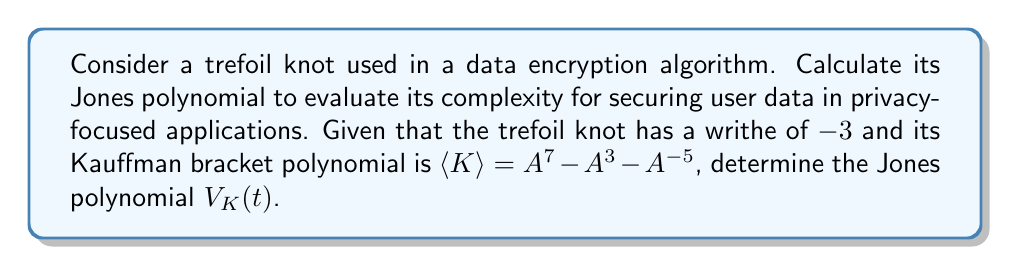Could you help me with this problem? To calculate the Jones polynomial for the trefoil knot, we'll follow these steps:

1. Recall the relation between the Jones polynomial $V_K(t)$ and the Kauffman bracket polynomial $\langle K \rangle$:

   $$V_K(t) = (-A^{-3})^{-w(K)} \cdot \langle K \rangle|_{A = t^{-1/4}}$$

   where $w(K)$ is the writhe of the knot.

2. We're given that the writhe $w(K) = -3$ and $\langle K \rangle = A^7 - A^3 - A^{-5}$.

3. Substitute these values into the formula:

   $$V_K(t) = (-A^{-3})^{-(-3)} \cdot (A^7 - A^3 - A^{-5})|_{A = t^{-1/4}}$$

4. Simplify the first part:

   $$V_K(t) = (-A^{-3})^3 \cdot (A^7 - A^3 - A^{-5})|_{A = t^{-1/4}}$$
   $$V_K(t) = -A^{-9} \cdot (A^7 - A^3 - A^{-5})|_{A = t^{-1/4}}$$

5. Now substitute $A = t^{-1/4}$:

   $$V_K(t) = -(t^{-1/4})^{-9} \cdot ((t^{-1/4})^7 - (t^{-1/4})^3 - (t^{-1/4})^{-5})$$

6. Simplify the exponents:

   $$V_K(t) = -t^{9/4} \cdot (t^{-7/4} - t^{-3/4} - t^{5/4})$$

7. Multiply through:

   $$V_K(t) = -t^{1/2} + t^{3/2} + t^{7/2}$$

This Jones polynomial represents the complexity of the trefoil knot in the context of data encryption, providing a mathematical measure of its intricacy for privacy-focused applications.
Answer: $V_K(t) = -t^{1/2} + t^{3/2} + t^{7/2}$ 